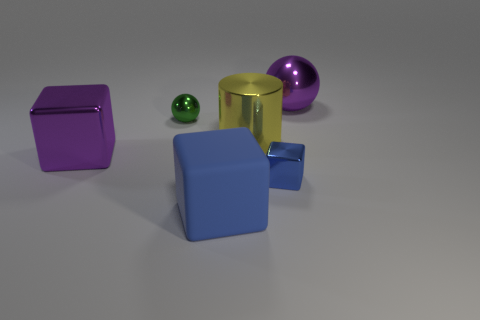Are there any other things that are made of the same material as the big blue thing?
Your response must be concise. No. What is the size of the thing that is the same color as the big ball?
Offer a terse response. Large. There is a blue object that is left of the yellow shiny thing; what is its material?
Provide a short and direct response. Rubber. What color is the big shiny cylinder?
Offer a very short reply. Yellow. Do the shiny block on the right side of the metallic cylinder and the purple object on the right side of the large purple block have the same size?
Provide a succinct answer. No. There is a metallic object that is in front of the yellow shiny thing and on the right side of the tiny green metal thing; what is its size?
Give a very brief answer. Small. There is a matte object that is the same shape as the blue metallic object; what is its color?
Keep it short and to the point. Blue. Is the number of large purple objects left of the tiny green sphere greater than the number of blue matte cubes that are right of the purple ball?
Give a very brief answer. Yes. How many other things are the same shape as the small green shiny thing?
Provide a succinct answer. 1. Are there any purple things in front of the purple thing on the right side of the green shiny object?
Offer a terse response. Yes. 